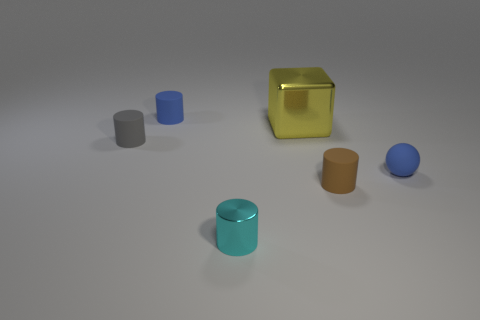What shape is the blue rubber object that is right of the object that is in front of the rubber cylinder that is on the right side of the tiny metal cylinder?
Give a very brief answer. Sphere. There is a object that is behind the large yellow cube; what size is it?
Offer a terse response. Small. The cyan shiny thing that is the same size as the gray rubber thing is what shape?
Your answer should be compact. Cylinder. What number of objects are blocks or metal objects right of the small cyan cylinder?
Your answer should be very brief. 1. There is a small blue thing on the right side of the blue rubber thing behind the blue rubber sphere; what number of metallic cylinders are to the right of it?
Offer a very short reply. 0. There is a small cylinder that is made of the same material as the large object; what is its color?
Give a very brief answer. Cyan. Is the size of the matte cylinder that is right of the blue matte cylinder the same as the small cyan shiny cylinder?
Give a very brief answer. Yes. How many things are blue metallic balls or cylinders?
Provide a short and direct response. 4. What is the material of the tiny object that is left of the blue matte object left of the rubber cylinder in front of the gray object?
Give a very brief answer. Rubber. There is a tiny cylinder that is right of the metallic cylinder; what is it made of?
Give a very brief answer. Rubber. 